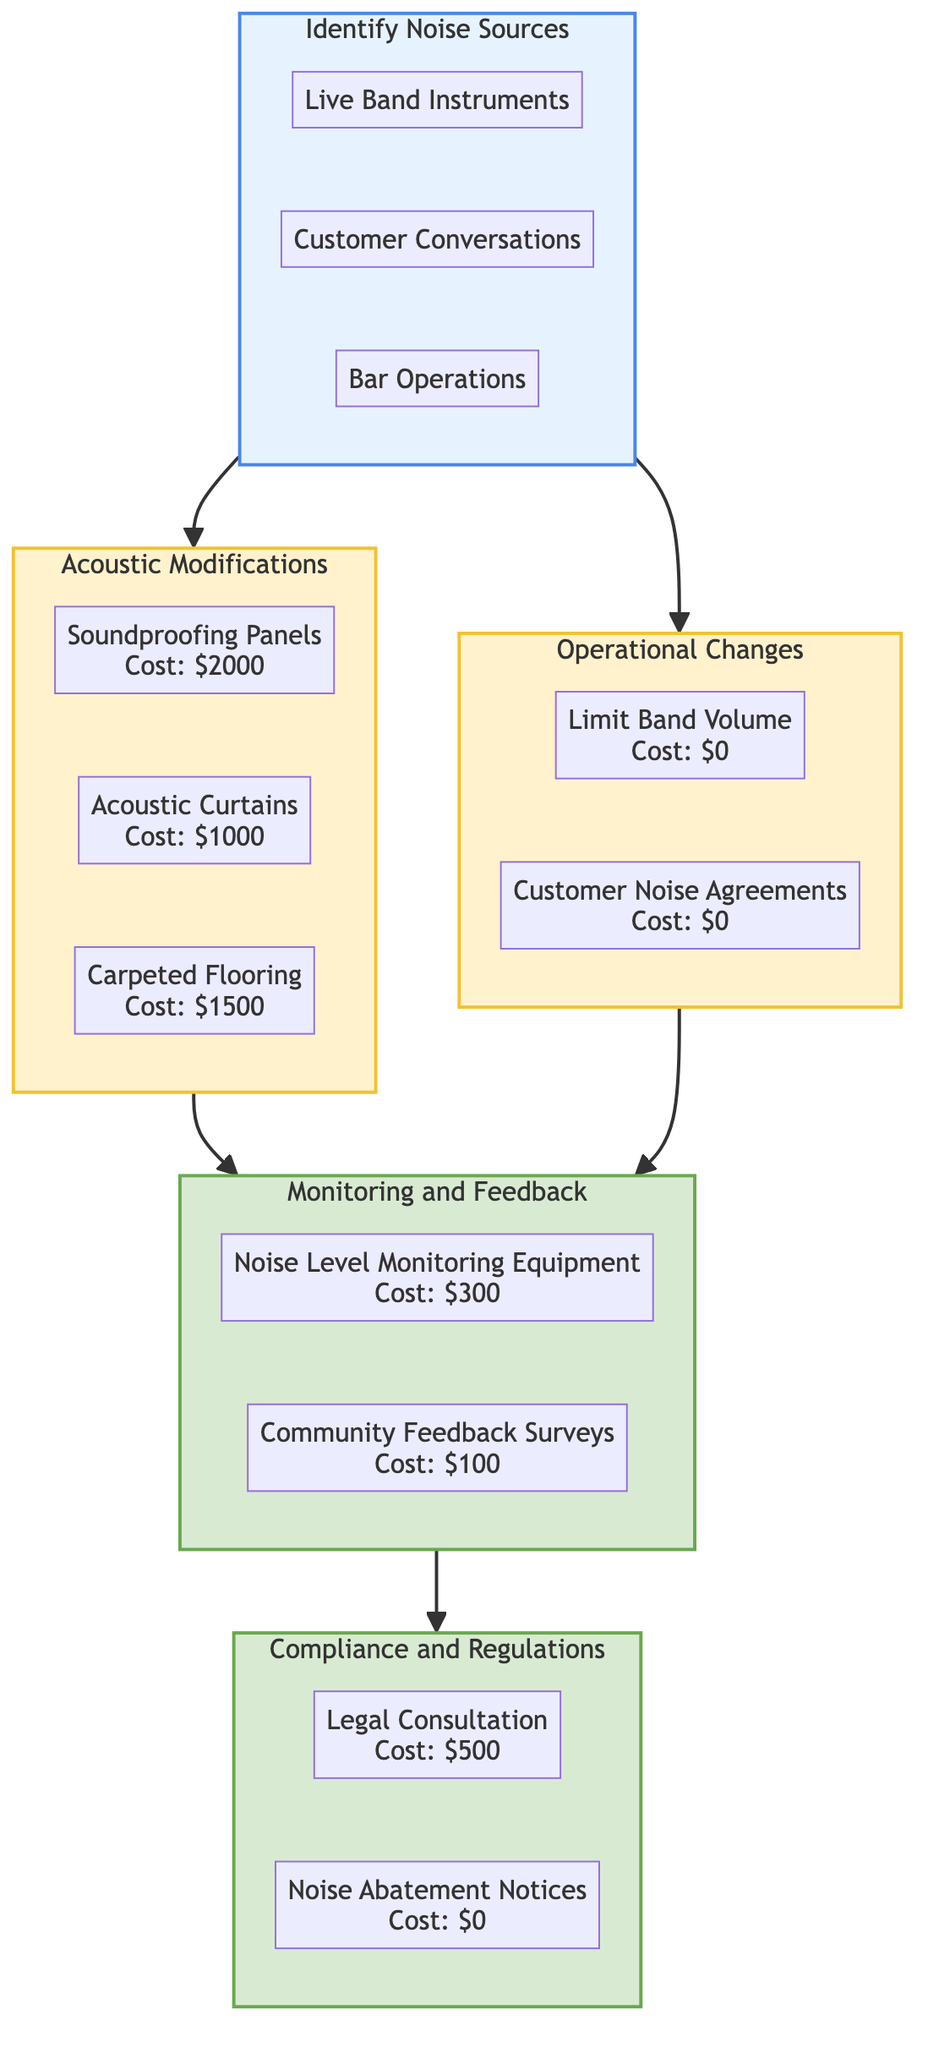What are the three identified noise sources? The diagram lists three noise sources within the "Identify Noise Sources" section: Live Band Instruments, Customer Conversations, and Bar Operations. This can be verified by inspecting the sub-elements under the first node.
Answer: Live Band Instruments, Customer Conversations, Bar Operations What is the cost of soundproofing panels? The "Acoustic Modifications" node provides detailed costs of various items, specifying that soundproofing panels cost $2000, as shown in the sub-elements of the second node.
Answer: 2000 Which process leads to both monitoring feedback and compliance? The diagram shows that both "Monitoring and Feedback" and "Compliance and Regulations" are outputs that come directly from the "Acoustic Modifications" and "Operational Changes" processes, indicating a convergence of their pathways.
Answer: Monitoring and Feedback, Compliance and Regulations How many items are listed under Operational Changes? In the "Operational Changes" section, there are two items mentioned: Limit Band Volume and Customer Noise Agreements. By counting these items in the sub-elements, we confirm that there are indeed two.
Answer: 2 What are the benefits of installing acoustic curtains? The benefits are explicitly stated in the "Acoustic Modifications" section under acoustic curtains, indicating a moderate reduction in noise transmission as a result of the installation of acoustic curtains.
Answer: Moderate reduction in noise transmission Which monitoring equipment has the lowest cost? Within the "Monitoring and Feedback" section, the costs are provided for two items: Noise Level Monitoring Equipment at $300 and Community Feedback Surveys at $100. Comparing these costs shows that the Community Feedback Surveys have the lowest cost.
Answer: 100 What kind of consultation is mentioned under the Compliance and Regulations section? The "Compliance and Regulations" node indicates that a "Legal Consultation" is mentioned as part of ensuring adherence to local noise ordinances. This can be seen within the sub-elements of the output section.
Answer: Legal Consultation What is the benefit of limiting band volume? In the "Operational Changes" section, the benefit of limiting band volume is stated as providing immediate reduction in noise levels. This is noted specifically as part of the advantages associated with operational changes.
Answer: Immediate reduction in noise levels What does the noise abatement notice cost? The "Compliance and Regulations" section states that the cost for "Noise Abatement Notices" is $0, indicating it requires no financial investment. This is clear upon reviewing the specific details under this output.
Answer: 0 